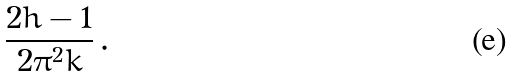<formula> <loc_0><loc_0><loc_500><loc_500>\frac { 2 h - 1 } { 2 \pi ^ { 2 } k } \, .</formula> 